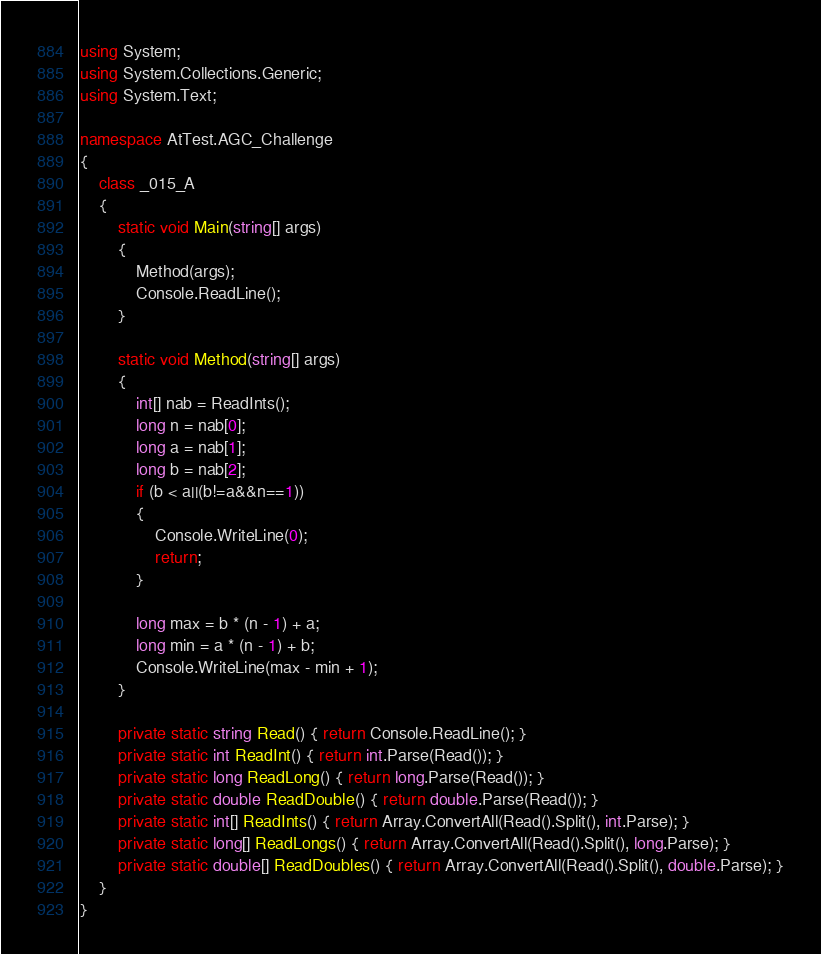Convert code to text. <code><loc_0><loc_0><loc_500><loc_500><_C#_>using System;
using System.Collections.Generic;
using System.Text;

namespace AtTest.AGC_Challenge
{
    class _015_A
    {
        static void Main(string[] args)
        {
            Method(args);
            Console.ReadLine();
        }

        static void Method(string[] args)
        {
            int[] nab = ReadInts();
            long n = nab[0];
            long a = nab[1];
            long b = nab[2];
            if (b < a||(b!=a&&n==1))
            {
                Console.WriteLine(0);
                return;
            }

            long max = b * (n - 1) + a;
            long min = a * (n - 1) + b;
            Console.WriteLine(max - min + 1);
        }

        private static string Read() { return Console.ReadLine(); }
        private static int ReadInt() { return int.Parse(Read()); }
        private static long ReadLong() { return long.Parse(Read()); }
        private static double ReadDouble() { return double.Parse(Read()); }
        private static int[] ReadInts() { return Array.ConvertAll(Read().Split(), int.Parse); }
        private static long[] ReadLongs() { return Array.ConvertAll(Read().Split(), long.Parse); }
        private static double[] ReadDoubles() { return Array.ConvertAll(Read().Split(), double.Parse); }
    }
}
</code> 